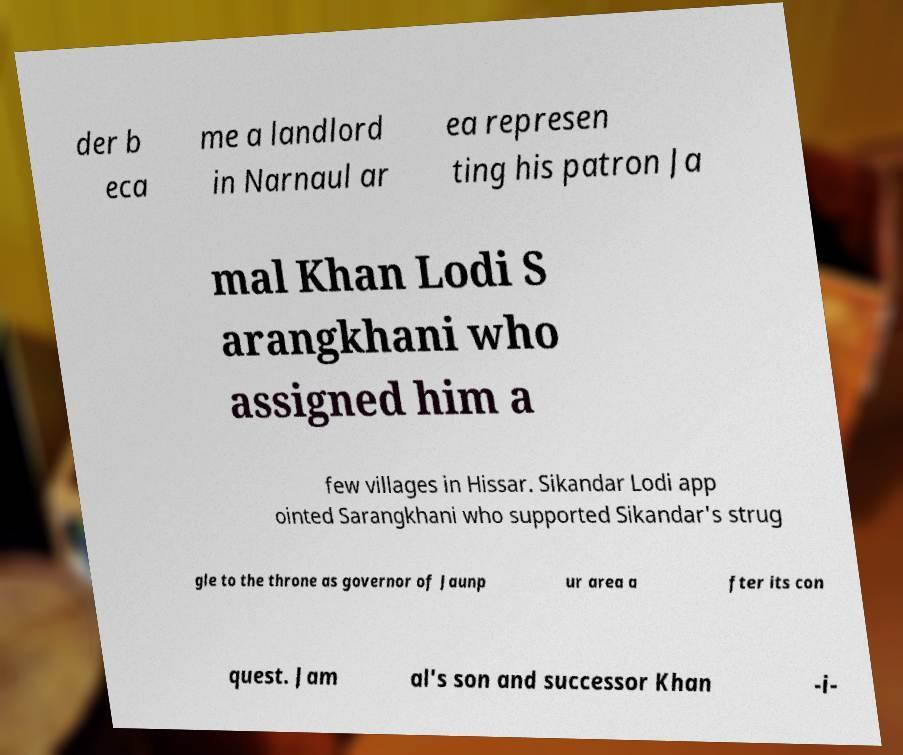What messages or text are displayed in this image? I need them in a readable, typed format. der b eca me a landlord in Narnaul ar ea represen ting his patron Ja mal Khan Lodi S arangkhani who assigned him a few villages in Hissar. Sikandar Lodi app ointed Sarangkhani who supported Sikandar's strug gle to the throne as governor of Jaunp ur area a fter its con quest. Jam al's son and successor Khan -i- 